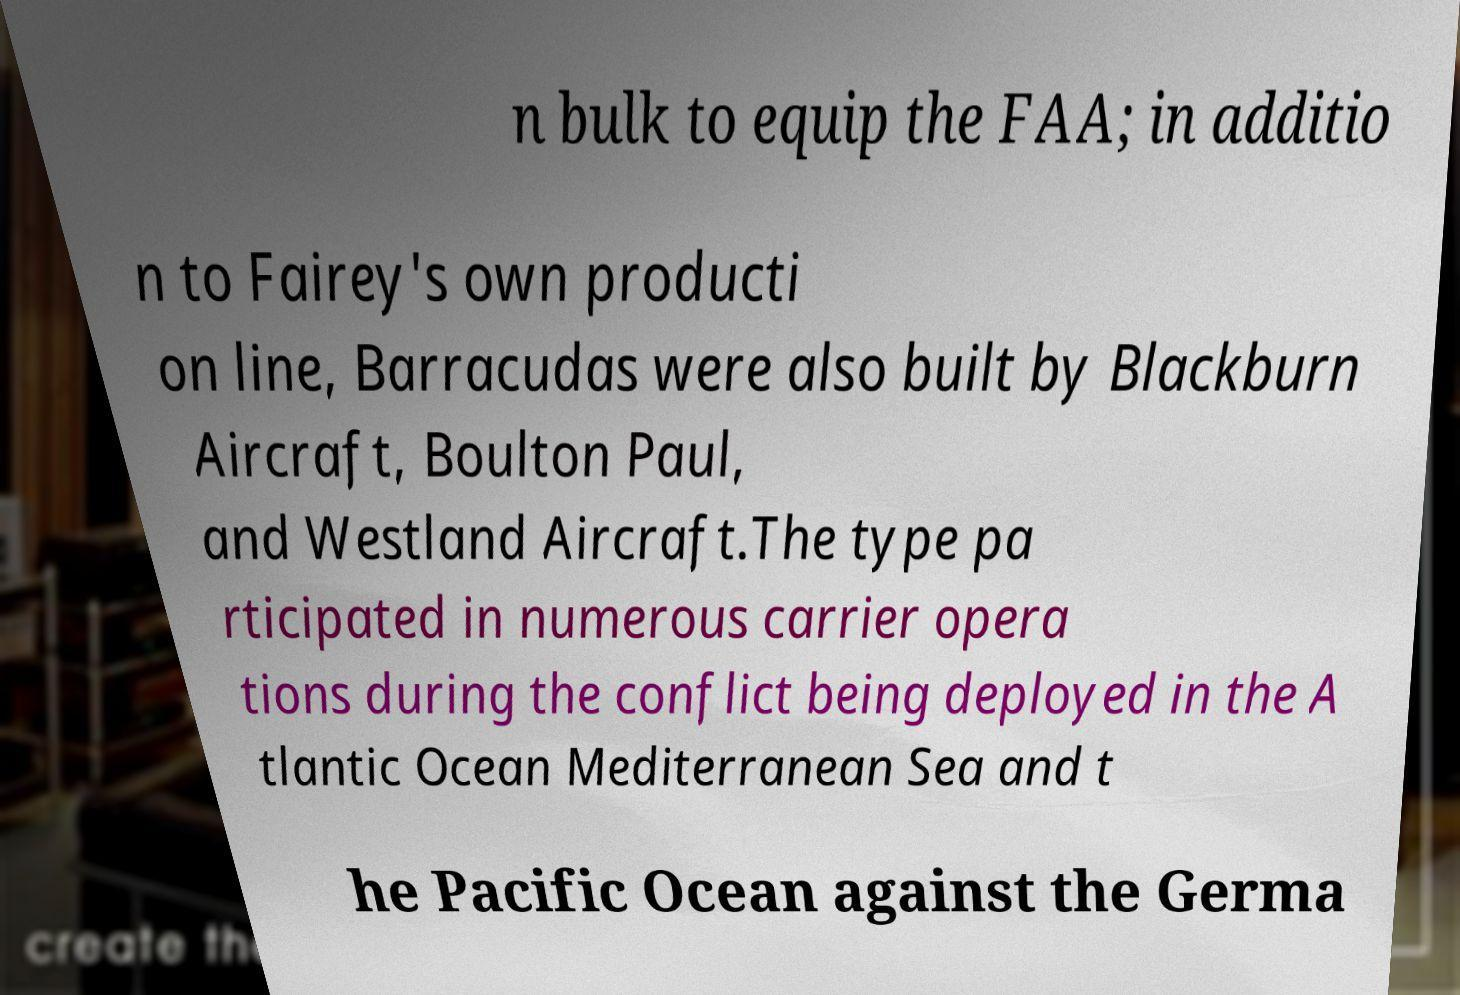Please identify and transcribe the text found in this image. n bulk to equip the FAA; in additio n to Fairey's own producti on line, Barracudas were also built by Blackburn Aircraft, Boulton Paul, and Westland Aircraft.The type pa rticipated in numerous carrier opera tions during the conflict being deployed in the A tlantic Ocean Mediterranean Sea and t he Pacific Ocean against the Germa 